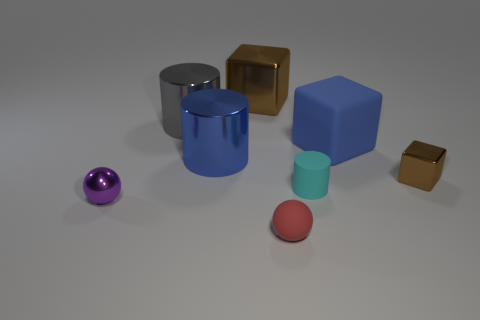Is there any other thing that is the same size as the purple shiny thing?
Offer a very short reply. Yes. Are there any matte things right of the small cyan object?
Offer a very short reply. Yes. There is a red object that is the same material as the big blue cube; what is its size?
Your answer should be very brief. Small. What number of cyan rubber things are the same shape as the big blue matte object?
Your answer should be compact. 0. Does the large brown cube have the same material as the cylinder in front of the tiny brown block?
Offer a terse response. No. Is the number of red matte balls behind the large gray shiny object greater than the number of cyan rubber things?
Provide a succinct answer. No. What shape is the big shiny thing that is the same color as the matte block?
Your response must be concise. Cylinder. Are there any cubes that have the same material as the red sphere?
Provide a succinct answer. Yes. Does the small purple object that is in front of the large brown thing have the same material as the large thing on the right side of the tiny cyan rubber cylinder?
Offer a terse response. No. Is the number of large brown blocks to the right of the large blue matte block the same as the number of brown shiny blocks that are behind the large blue metal object?
Your response must be concise. No. 